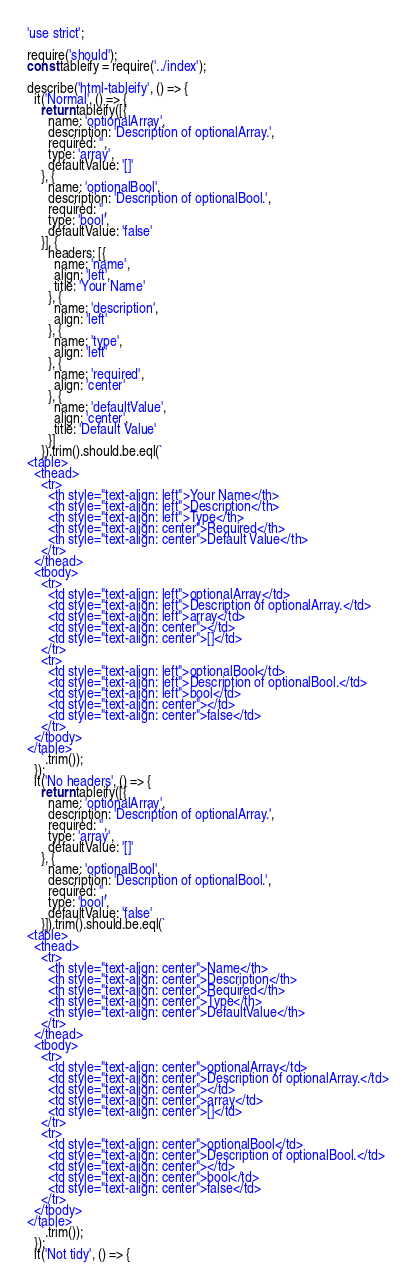<code> <loc_0><loc_0><loc_500><loc_500><_JavaScript_>'use strict';

require('should');
const tableify = require('../index');

describe('html-tableify', () => {
  it('Normal', () => {
    return tableify([{
      name: 'optionalArray',
      description: 'Description of optionalArray.',
      required: '',
      type: 'array',
      defaultValue: '[]'
    }, {
      name: 'optionalBool',
      description: 'Description of optionalBool.',
      required: '',
      type: 'bool',
      defaultValue: 'false'
    }], {
      headers: [{
        name: 'name',
        align: 'left',
        title: 'Your Name'
      }, {
        name: 'description',
        align: 'left'
      }, {
        name: 'type',
        align: 'left'
      }, {
        name: 'required',
        align: 'center'
      }, {
        name: 'defaultValue',
        align: 'center',
        title: 'Default Value'
      }]
    }).trim().should.be.eql(`
<table>
  <thead>
    <tr>
      <th style="text-align: left">Your Name</th>
      <th style="text-align: left">Description</th>
      <th style="text-align: left">Type</th>
      <th style="text-align: center">Required</th>
      <th style="text-align: center">Default Value</th>
    </tr>
  </thead>
  <tbody>
    <tr>
      <td style="text-align: left">optionalArray</td>
      <td style="text-align: left">Description of optionalArray.</td>
      <td style="text-align: left">array</td>
      <td style="text-align: center"></td>
      <td style="text-align: center">[]</td>
    </tr>
    <tr>
      <td style="text-align: left">optionalBool</td>
      <td style="text-align: left">Description of optionalBool.</td>
      <td style="text-align: left">bool</td>
      <td style="text-align: center"></td>
      <td style="text-align: center">false</td>
    </tr>
  </tbody>
</table>
    `.trim());
  });
  it('No headers', () => {
    return tableify([{
      name: 'optionalArray',
      description: 'Description of optionalArray.',
      required: '',
      type: 'array',
      defaultValue: '[]'
    }, {
      name: 'optionalBool',
      description: 'Description of optionalBool.',
      required: '',
      type: 'bool',
      defaultValue: 'false'
    }]).trim().should.be.eql(`
<table>
  <thead>
    <tr>
      <th style="text-align: center">Name</th>
      <th style="text-align: center">Description</th>
      <th style="text-align: center">Required</th>
      <th style="text-align: center">Type</th>
      <th style="text-align: center">DefaultValue</th>
    </tr>
  </thead>
  <tbody>
    <tr>
      <td style="text-align: center">optionalArray</td>
      <td style="text-align: center">Description of optionalArray.</td>
      <td style="text-align: center"></td>
      <td style="text-align: center">array</td>
      <td style="text-align: center">[]</td>
    </tr>
    <tr>
      <td style="text-align: center">optionalBool</td>
      <td style="text-align: center">Description of optionalBool.</td>
      <td style="text-align: center"></td>
      <td style="text-align: center">bool</td>
      <td style="text-align: center">false</td>
    </tr>
  </tbody>
</table>
    `.trim());
  });
  it('Not tidy', () => {</code> 